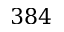<formula> <loc_0><loc_0><loc_500><loc_500>3 8 4</formula> 